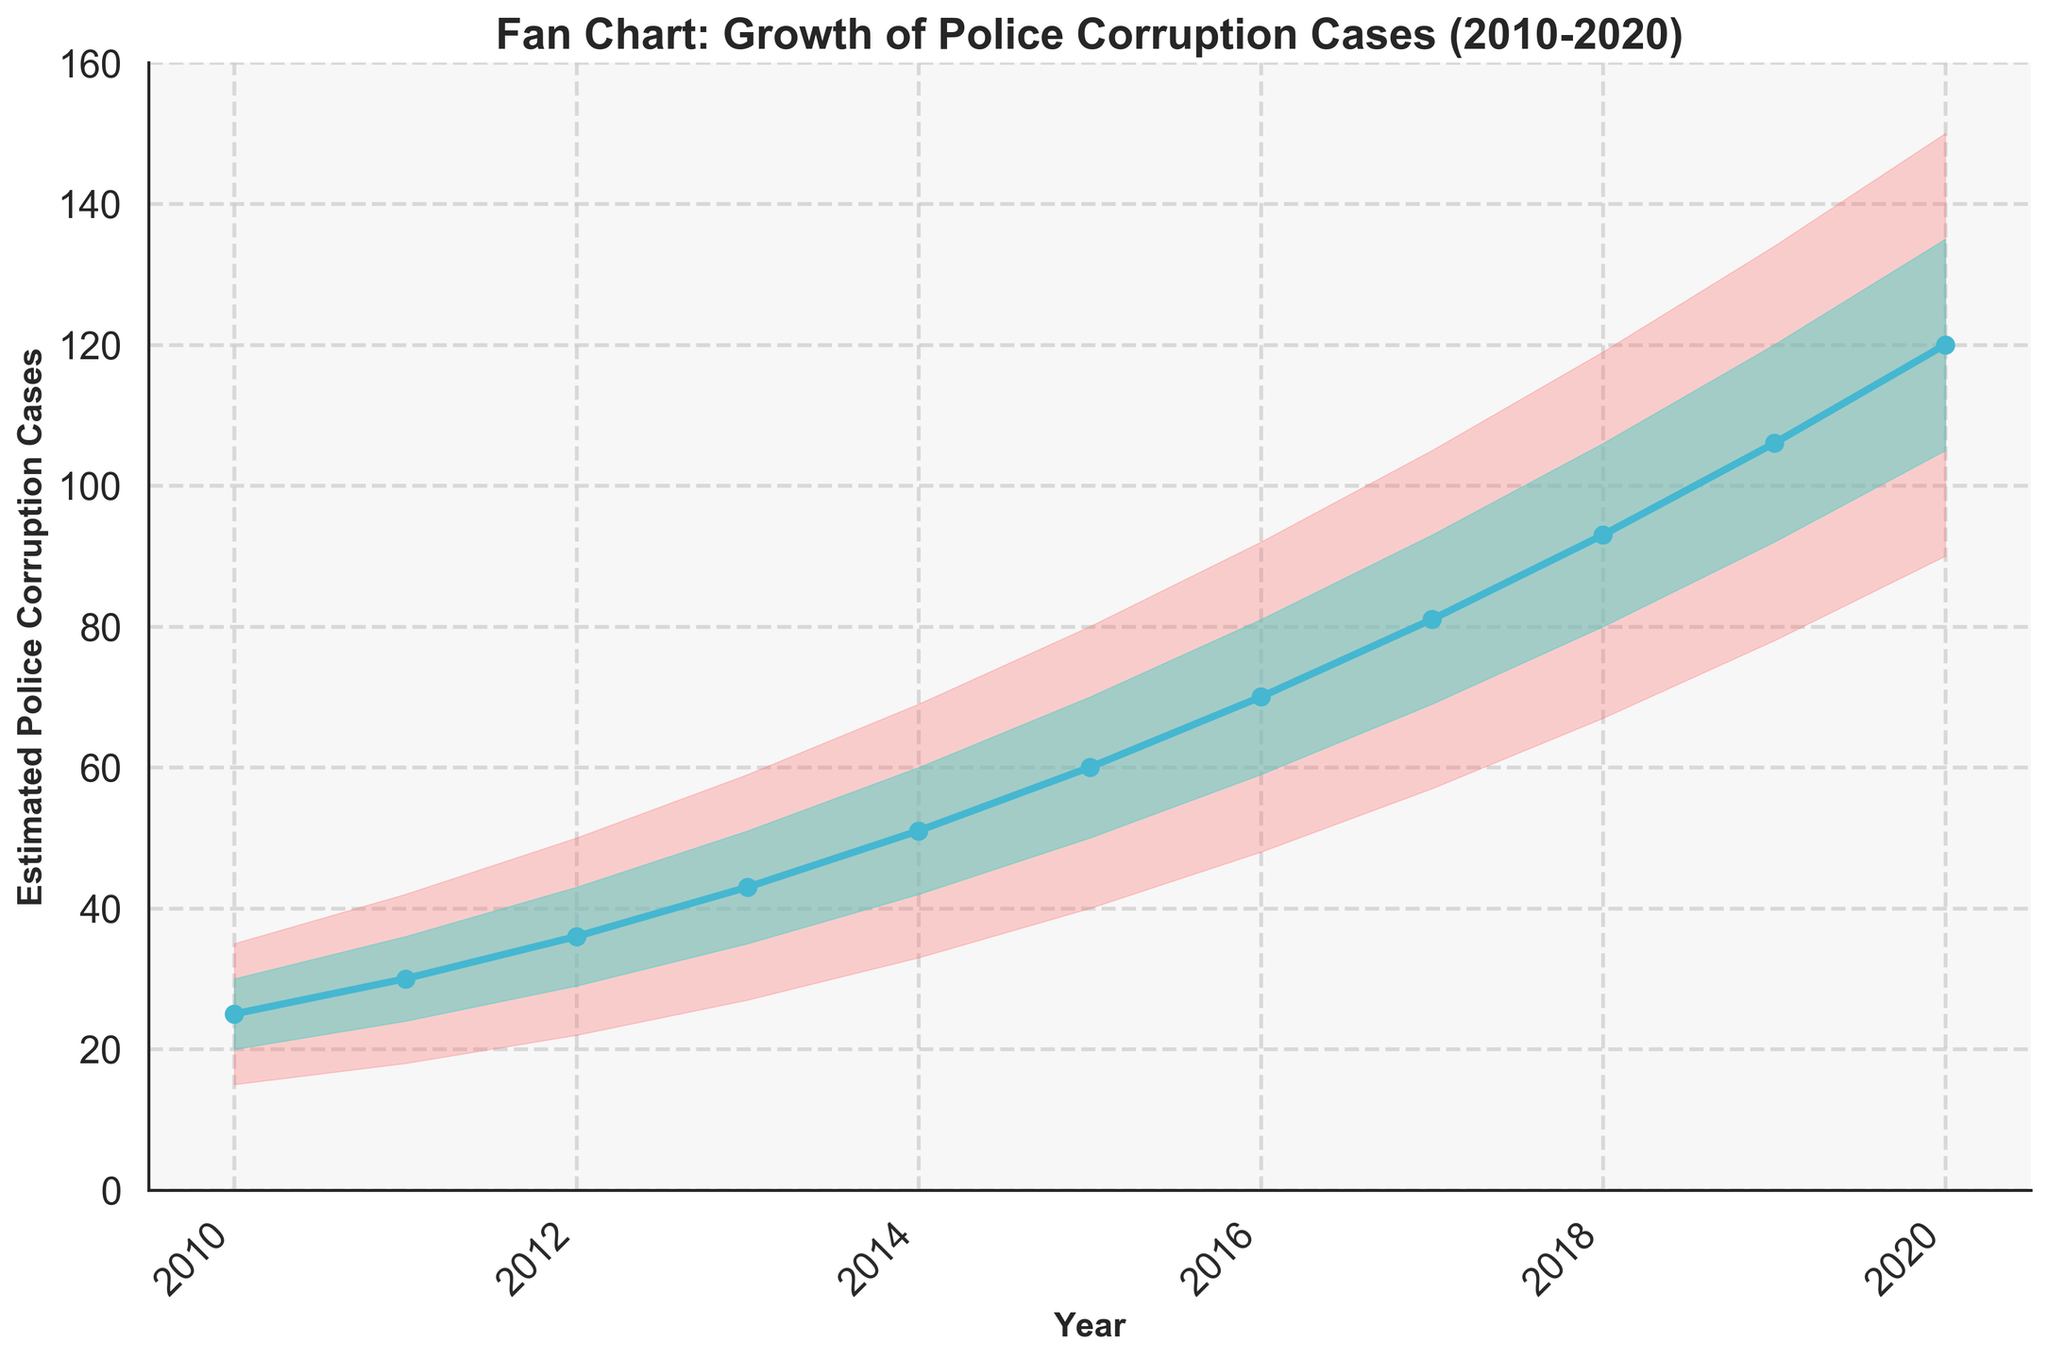What is the title of the figure? The title of the figure is displayed prominently at the top of the chart.
Answer: Fan Chart: Growth of Police Corruption Cases (2010-2020) How many years are represented in the chart? The x-axis shows the range of years covered in the chart. By counting from 2010 to 2020, we see there are 11 years represented.
Answer: 11 What does the median line represent in the chart? The median line is the central line in the Fan chart, typically drawn with a specific color (blue in this case), and it represents the median estimated number of police corruption cases per year.
Answer: The median estimated police corruption cases per year What is the estimated median number of police corruption cases in 2015? The median estimate for each year is marked by the central line. Find the point corresponding to 2015 on this line.
Answer: 60 Between which years did the median estimated police corruption cases experience the largest increase? To determine the largest increase, calculate the difference in median cases year over year and find the largest. The largest jump appears from 2010 to 2020.
Answer: 2019 to 2020 What is the range of estimated police corruption cases in 2018? The range can be found by subtracting the lower bound value from the upper bound value for 2018. So, 119 - 67 = 52
Answer: 52 Which year shows the highest level of uncertainty in estimating police corruption cases? The uncertainty can be assessed by the width of the shaded area in the Fan chart. The widest range is between the lower and upper bounds in 2020.
Answer: 2020 How much did the lower bound of estimated police corruption cases change from 2010 to 2020? Subtract the value in 2010 from the value in 2020 for the lower bound estimates: 90 - 15 = 75
Answer: 75 In which year did the lower middle estimate first surpass the upper middle estimate of the previous year? This requires comparing the lower middle estimate for each year with the previous year's upper middle estimate to identify when this first occurs. It happens from 2019 (Lower Middle: 92) surpassing 2018 (Upper Middle: 106).
Answer: 2018 to 2019 